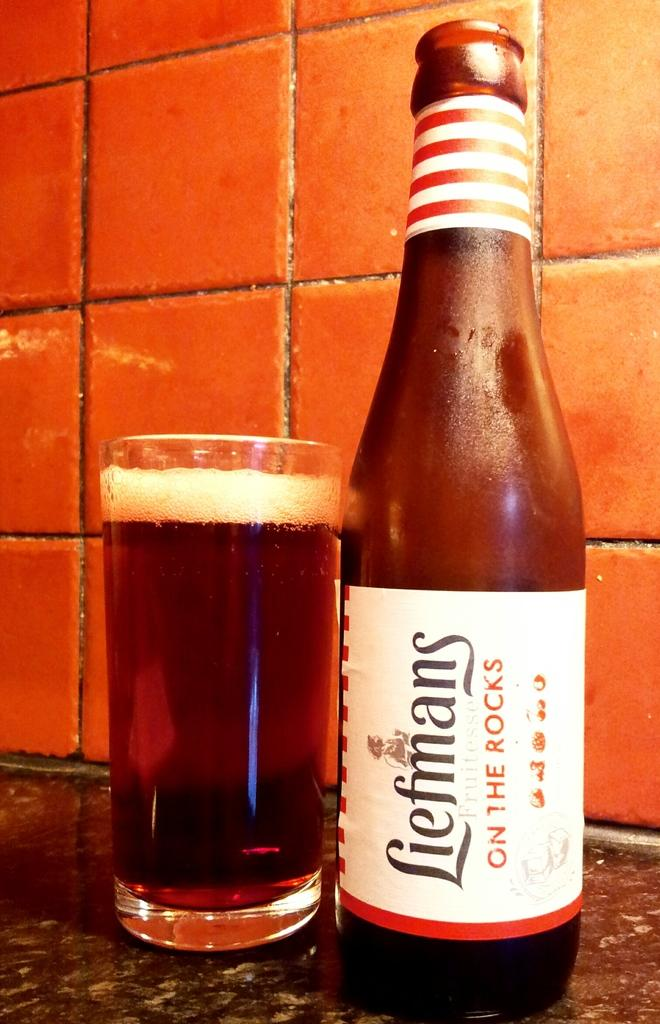<image>
Write a terse but informative summary of the picture. A bottle of Liefmans on the rocks is to the right of the glass. 